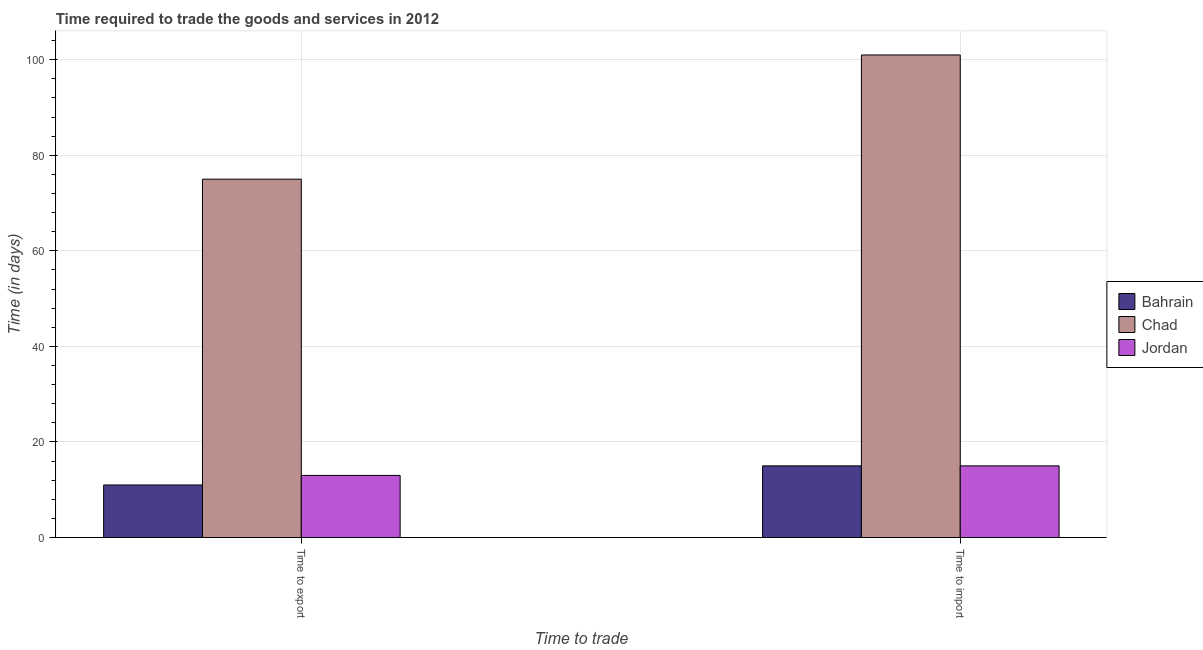Are the number of bars per tick equal to the number of legend labels?
Your response must be concise. Yes. Are the number of bars on each tick of the X-axis equal?
Your answer should be compact. Yes. What is the label of the 1st group of bars from the left?
Give a very brief answer. Time to export. What is the time to import in Chad?
Ensure brevity in your answer.  101. Across all countries, what is the maximum time to import?
Give a very brief answer. 101. Across all countries, what is the minimum time to import?
Ensure brevity in your answer.  15. In which country was the time to export maximum?
Your answer should be compact. Chad. In which country was the time to import minimum?
Give a very brief answer. Bahrain. What is the total time to export in the graph?
Offer a very short reply. 99. What is the difference between the time to import in Bahrain and that in Jordan?
Ensure brevity in your answer.  0. What is the difference between the time to import in Bahrain and the time to export in Jordan?
Offer a terse response. 2. What is the average time to import per country?
Provide a short and direct response. 43.67. What is the difference between the time to export and time to import in Jordan?
Your answer should be compact. -2. What is the ratio of the time to export in Jordan to that in Bahrain?
Give a very brief answer. 1.18. What does the 3rd bar from the left in Time to import represents?
Your response must be concise. Jordan. What does the 3rd bar from the right in Time to export represents?
Provide a short and direct response. Bahrain. How many bars are there?
Your response must be concise. 6. Are all the bars in the graph horizontal?
Give a very brief answer. No. How many countries are there in the graph?
Your answer should be compact. 3. Are the values on the major ticks of Y-axis written in scientific E-notation?
Provide a succinct answer. No. Does the graph contain grids?
Make the answer very short. Yes. Where does the legend appear in the graph?
Give a very brief answer. Center right. How many legend labels are there?
Provide a short and direct response. 3. What is the title of the graph?
Make the answer very short. Time required to trade the goods and services in 2012. Does "Sub-Saharan Africa (developing only)" appear as one of the legend labels in the graph?
Give a very brief answer. No. What is the label or title of the X-axis?
Keep it short and to the point. Time to trade. What is the label or title of the Y-axis?
Offer a very short reply. Time (in days). What is the Time (in days) of Chad in Time to export?
Your response must be concise. 75. What is the Time (in days) in Jordan in Time to export?
Offer a terse response. 13. What is the Time (in days) of Bahrain in Time to import?
Your answer should be very brief. 15. What is the Time (in days) of Chad in Time to import?
Ensure brevity in your answer.  101. What is the Time (in days) of Jordan in Time to import?
Make the answer very short. 15. Across all Time to trade, what is the maximum Time (in days) in Chad?
Provide a succinct answer. 101. Across all Time to trade, what is the minimum Time (in days) of Bahrain?
Provide a succinct answer. 11. Across all Time to trade, what is the minimum Time (in days) of Jordan?
Keep it short and to the point. 13. What is the total Time (in days) in Bahrain in the graph?
Your answer should be compact. 26. What is the total Time (in days) of Chad in the graph?
Ensure brevity in your answer.  176. What is the difference between the Time (in days) of Chad in Time to export and that in Time to import?
Keep it short and to the point. -26. What is the difference between the Time (in days) in Bahrain in Time to export and the Time (in days) in Chad in Time to import?
Offer a very short reply. -90. What is the difference between the Time (in days) of Bahrain in Time to export and the Time (in days) of Jordan in Time to import?
Your answer should be compact. -4. What is the difference between the Time (in days) in Chad in Time to export and the Time (in days) in Jordan in Time to import?
Your answer should be very brief. 60. What is the difference between the Time (in days) of Bahrain and Time (in days) of Chad in Time to export?
Your answer should be compact. -64. What is the difference between the Time (in days) in Bahrain and Time (in days) in Jordan in Time to export?
Keep it short and to the point. -2. What is the difference between the Time (in days) of Chad and Time (in days) of Jordan in Time to export?
Keep it short and to the point. 62. What is the difference between the Time (in days) of Bahrain and Time (in days) of Chad in Time to import?
Offer a very short reply. -86. What is the difference between the Time (in days) in Chad and Time (in days) in Jordan in Time to import?
Offer a very short reply. 86. What is the ratio of the Time (in days) in Bahrain in Time to export to that in Time to import?
Offer a terse response. 0.73. What is the ratio of the Time (in days) of Chad in Time to export to that in Time to import?
Ensure brevity in your answer.  0.74. What is the ratio of the Time (in days) in Jordan in Time to export to that in Time to import?
Offer a terse response. 0.87. What is the difference between the highest and the second highest Time (in days) in Chad?
Keep it short and to the point. 26. What is the difference between the highest and the lowest Time (in days) of Bahrain?
Give a very brief answer. 4. 